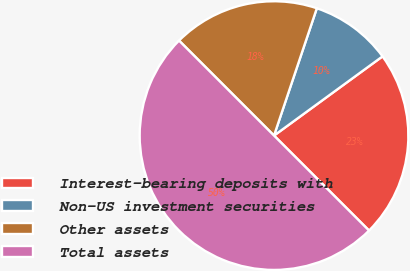Convert chart to OTSL. <chart><loc_0><loc_0><loc_500><loc_500><pie_chart><fcel>Interest-bearing deposits with<fcel>Non-US investment securities<fcel>Other assets<fcel>Total assets<nl><fcel>22.53%<fcel>9.8%<fcel>17.66%<fcel>50.0%<nl></chart> 